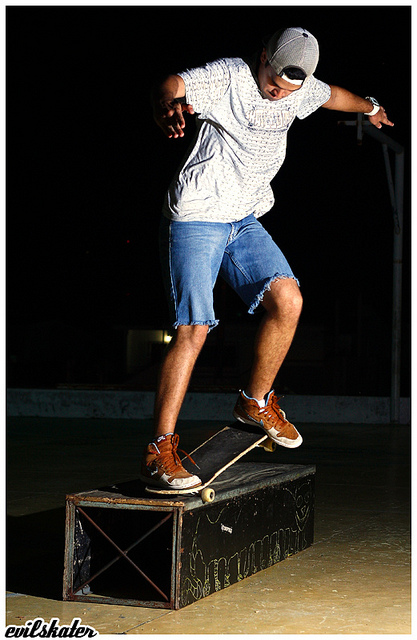Please identify all text content in this image. evilskater 